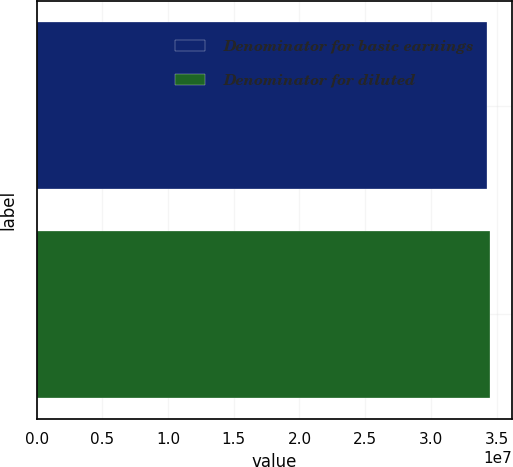<chart> <loc_0><loc_0><loc_500><loc_500><bar_chart><fcel>Denominator for basic earnings<fcel>Denominator for diluted<nl><fcel>3.42893e+07<fcel>3.44769e+07<nl></chart> 